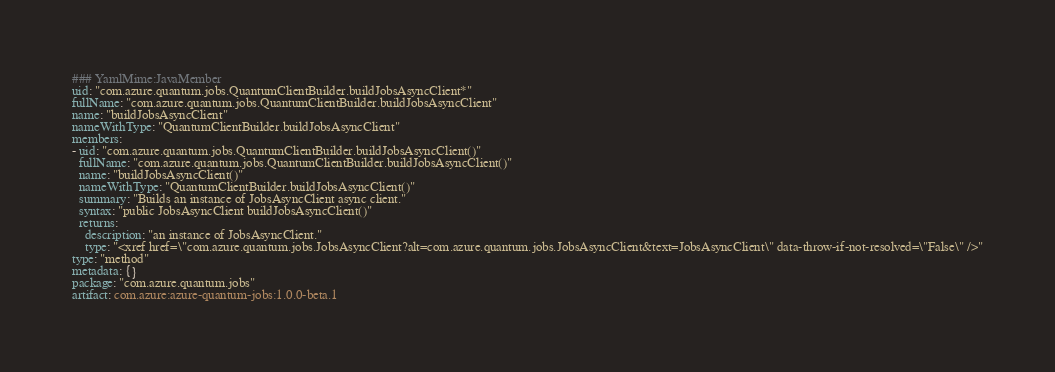Convert code to text. <code><loc_0><loc_0><loc_500><loc_500><_YAML_>### YamlMime:JavaMember
uid: "com.azure.quantum.jobs.QuantumClientBuilder.buildJobsAsyncClient*"
fullName: "com.azure.quantum.jobs.QuantumClientBuilder.buildJobsAsyncClient"
name: "buildJobsAsyncClient"
nameWithType: "QuantumClientBuilder.buildJobsAsyncClient"
members:
- uid: "com.azure.quantum.jobs.QuantumClientBuilder.buildJobsAsyncClient()"
  fullName: "com.azure.quantum.jobs.QuantumClientBuilder.buildJobsAsyncClient()"
  name: "buildJobsAsyncClient()"
  nameWithType: "QuantumClientBuilder.buildJobsAsyncClient()"
  summary: "Builds an instance of JobsAsyncClient async client."
  syntax: "public JobsAsyncClient buildJobsAsyncClient()"
  returns:
    description: "an instance of JobsAsyncClient."
    type: "<xref href=\"com.azure.quantum.jobs.JobsAsyncClient?alt=com.azure.quantum.jobs.JobsAsyncClient&text=JobsAsyncClient\" data-throw-if-not-resolved=\"False\" />"
type: "method"
metadata: {}
package: "com.azure.quantum.jobs"
artifact: com.azure:azure-quantum-jobs:1.0.0-beta.1
</code> 